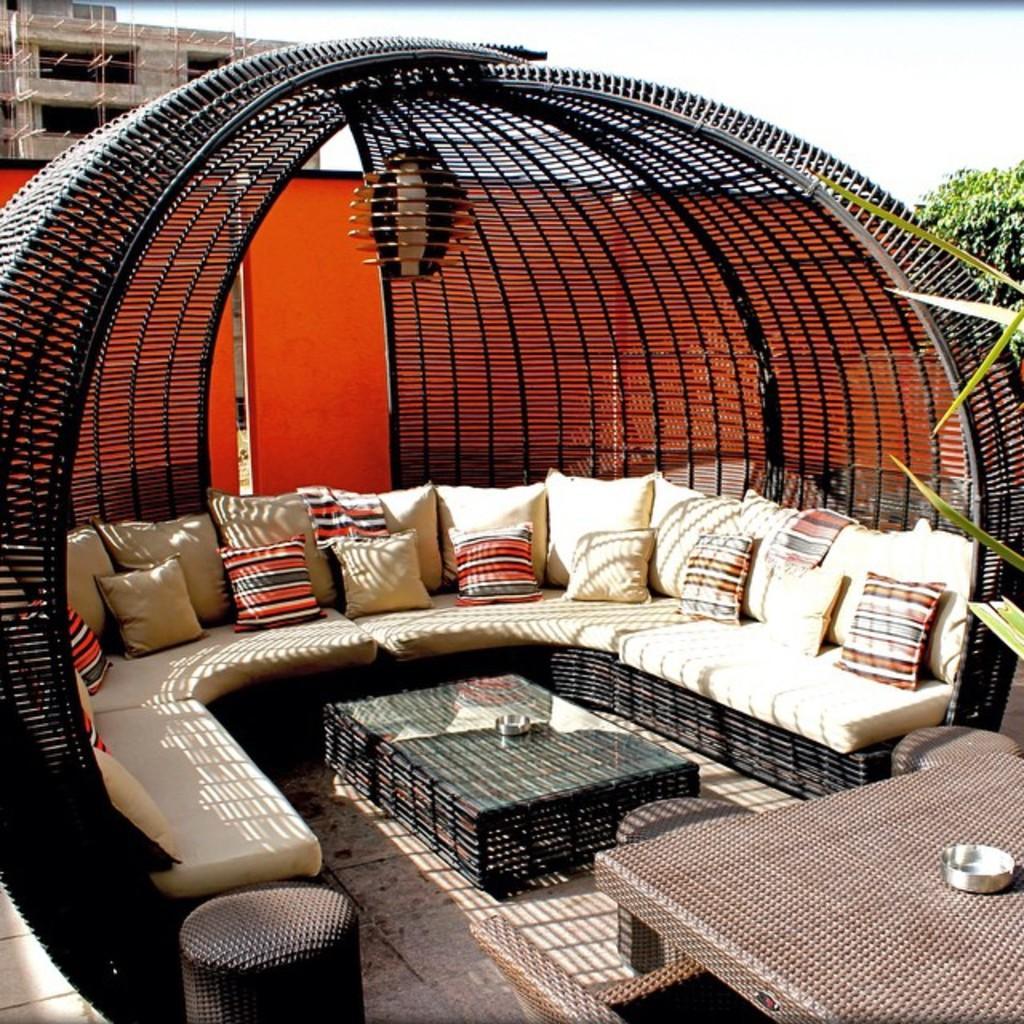How would you summarize this image in a sentence or two? At the top we can see sky. On the background we can see a building which is under construction. This is a tree. Here we can see a sofa, pillows on it, tables. 